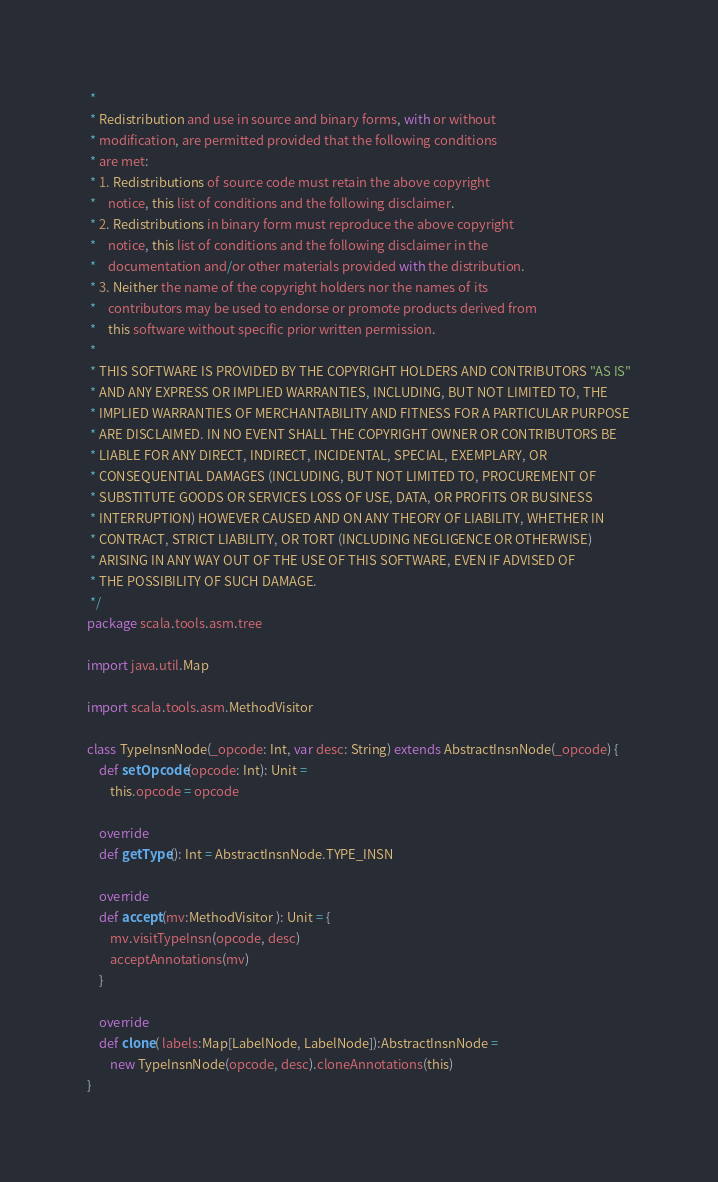Convert code to text. <code><loc_0><loc_0><loc_500><loc_500><_Scala_> *
 * Redistribution and use in source and binary forms, with or without
 * modification, are permitted provided that the following conditions
 * are met:
 * 1. Redistributions of source code must retain the above copyright
 *    notice, this list of conditions and the following disclaimer.
 * 2. Redistributions in binary form must reproduce the above copyright
 *    notice, this list of conditions and the following disclaimer in the
 *    documentation and/or other materials provided with the distribution.
 * 3. Neither the name of the copyright holders nor the names of its
 *    contributors may be used to endorse or promote products derived from
 *    this software without specific prior written permission.
 *
 * THIS SOFTWARE IS PROVIDED BY THE COPYRIGHT HOLDERS AND CONTRIBUTORS "AS IS"
 * AND ANY EXPRESS OR IMPLIED WARRANTIES, INCLUDING, BUT NOT LIMITED TO, THE
 * IMPLIED WARRANTIES OF MERCHANTABILITY AND FITNESS FOR A PARTICULAR PURPOSE
 * ARE DISCLAIMED. IN NO EVENT SHALL THE COPYRIGHT OWNER OR CONTRIBUTORS BE
 * LIABLE FOR ANY DIRECT, INDIRECT, INCIDENTAL, SPECIAL, EXEMPLARY, OR
 * CONSEQUENTIAL DAMAGES (INCLUDING, BUT NOT LIMITED TO, PROCUREMENT OF
 * SUBSTITUTE GOODS OR SERVICES LOSS OF USE, DATA, OR PROFITS OR BUSINESS
 * INTERRUPTION) HOWEVER CAUSED AND ON ANY THEORY OF LIABILITY, WHETHER IN
 * CONTRACT, STRICT LIABILITY, OR TORT (INCLUDING NEGLIGENCE OR OTHERWISE)
 * ARISING IN ANY WAY OUT OF THE USE OF THIS SOFTWARE, EVEN IF ADVISED OF
 * THE POSSIBILITY OF SUCH DAMAGE.
 */
package scala.tools.asm.tree

import java.util.Map

import scala.tools.asm.MethodVisitor

class TypeInsnNode(_opcode: Int, var desc: String) extends AbstractInsnNode(_opcode) {
    def setOpcode(opcode: Int): Unit =
        this.opcode = opcode

    override
    def getType(): Int = AbstractInsnNode.TYPE_INSN

    override
    def accept(mv:MethodVisitor ): Unit = {
        mv.visitTypeInsn(opcode, desc)
        acceptAnnotations(mv)
    }

    override
    def clone( labels:Map[LabelNode, LabelNode]):AbstractInsnNode =
        new TypeInsnNode(opcode, desc).cloneAnnotations(this)
}
</code> 